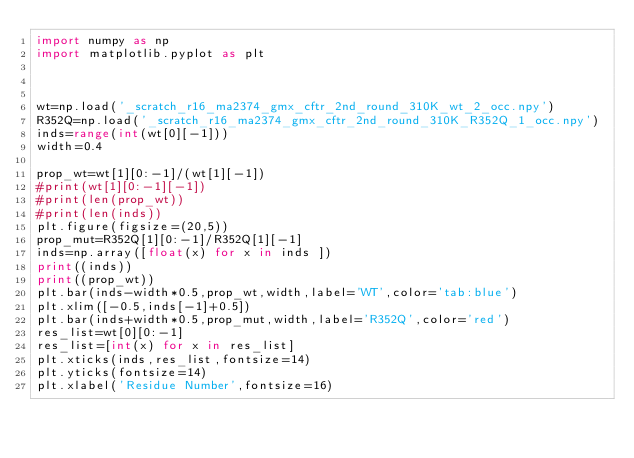<code> <loc_0><loc_0><loc_500><loc_500><_Python_>import numpy as np
import matplotlib.pyplot as plt 



wt=np.load('_scratch_r16_ma2374_gmx_cftr_2nd_round_310K_wt_2_occ.npy')
R352Q=np.load('_scratch_r16_ma2374_gmx_cftr_2nd_round_310K_R352Q_1_occ.npy')
inds=range(int(wt[0][-1]))
width=0.4

prop_wt=wt[1][0:-1]/(wt[1][-1])
#print(wt[1][0:-1][-1])
#print(len(prop_wt))
#print(len(inds))
plt.figure(figsize=(20,5))
prop_mut=R352Q[1][0:-1]/R352Q[1][-1]
inds=np.array([float(x) for x in inds ])
print((inds))
print((prop_wt))
plt.bar(inds-width*0.5,prop_wt,width,label='WT',color='tab:blue')
plt.xlim([-0.5,inds[-1]+0.5])
plt.bar(inds+width*0.5,prop_mut,width,label='R352Q',color='red')
res_list=wt[0][0:-1]
res_list=[int(x) for x in res_list]
plt.xticks(inds,res_list,fontsize=14)
plt.yticks(fontsize=14)
plt.xlabel('Residue Number',fontsize=16)</code> 